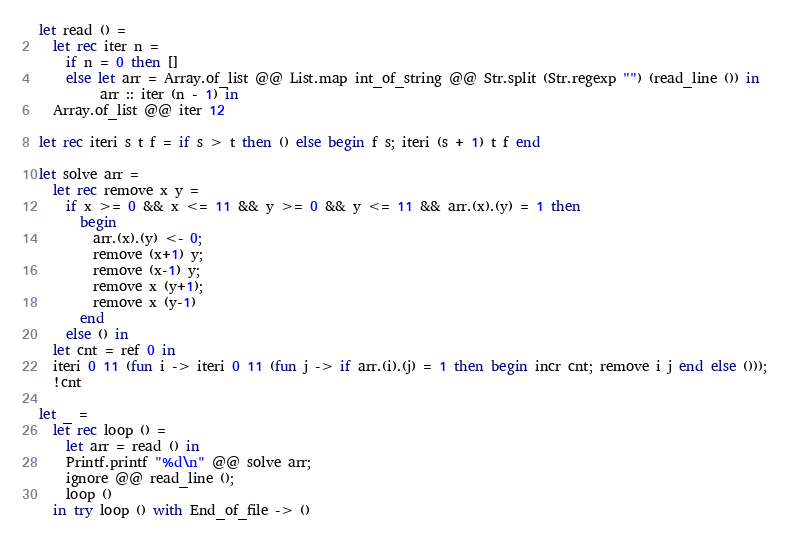<code> <loc_0><loc_0><loc_500><loc_500><_OCaml_>let read () = 
  let rec iter n =
    if n = 0 then []
    else let arr = Array.of_list @@ List.map int_of_string @@ Str.split (Str.regexp "") (read_line ()) in
         arr :: iter (n - 1) in
  Array.of_list @@ iter 12
       
let rec iteri s t f = if s > t then () else begin f s; iteri (s + 1) t f end

let solve arr =
  let rec remove x y =
    if x >= 0 && x <= 11 && y >= 0 && y <= 11 && arr.(x).(y) = 1 then 
      begin
        arr.(x).(y) <- 0;
        remove (x+1) y;
        remove (x-1) y;
        remove x (y+1);
        remove x (y-1)
      end
    else () in
  let cnt = ref 0 in
  iteri 0 11 (fun i -> iteri 0 11 (fun j -> if arr.(i).(j) = 1 then begin incr cnt; remove i j end else ()));
  !cnt

let _ = 
  let rec loop () =
    let arr = read () in
    Printf.printf "%d\n" @@ solve arr;
    ignore @@ read_line ();
    loop ()
  in try loop () with End_of_file -> ()</code> 